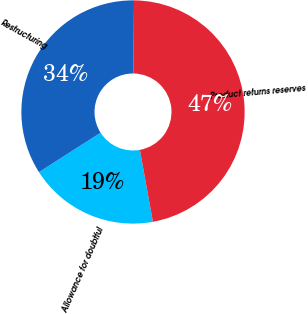Convert chart to OTSL. <chart><loc_0><loc_0><loc_500><loc_500><pie_chart><fcel>Allowance for doubtful<fcel>Product returns reserves<fcel>Restructuring<nl><fcel>18.8%<fcel>47.0%<fcel>34.2%<nl></chart> 